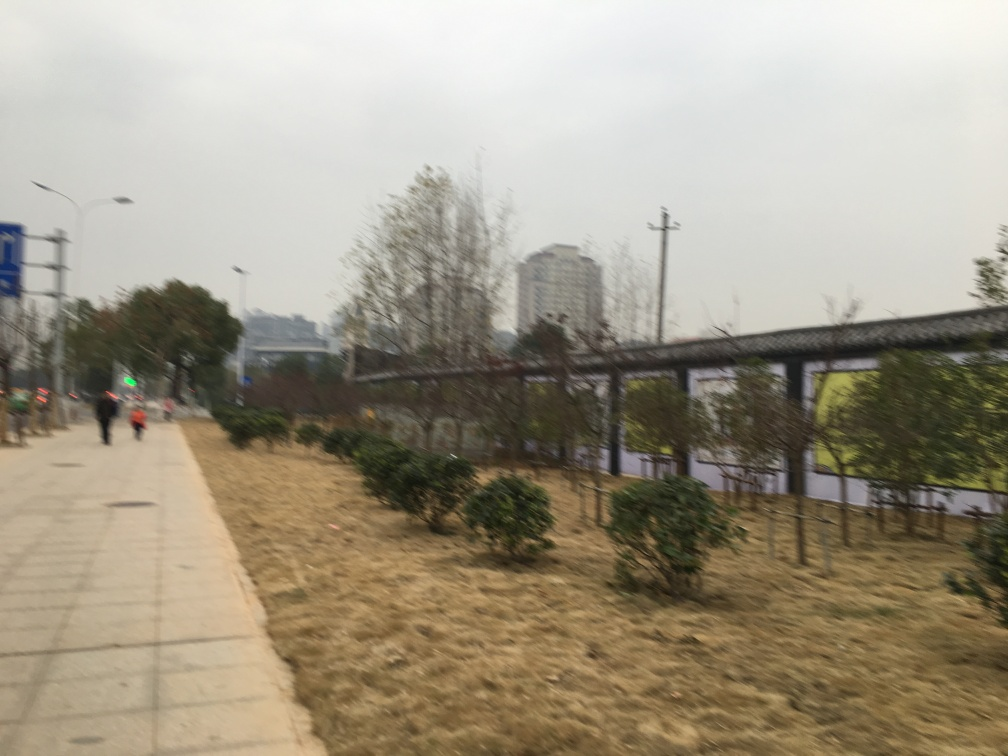Can you describe the overall mood or atmosphere this image seems to convey? The image conveys a somewhat somber and quiet mood, likely due to the muted colors, the hazy or overcast sky, and the absence of vivid, eye-catching elements. It also gives a sense of stillness, which might be due to the seemingly deserted path and tranquil surroundings. 